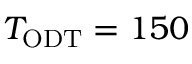<formula> <loc_0><loc_0><loc_500><loc_500>T _ { O D T } = 1 5 0</formula> 